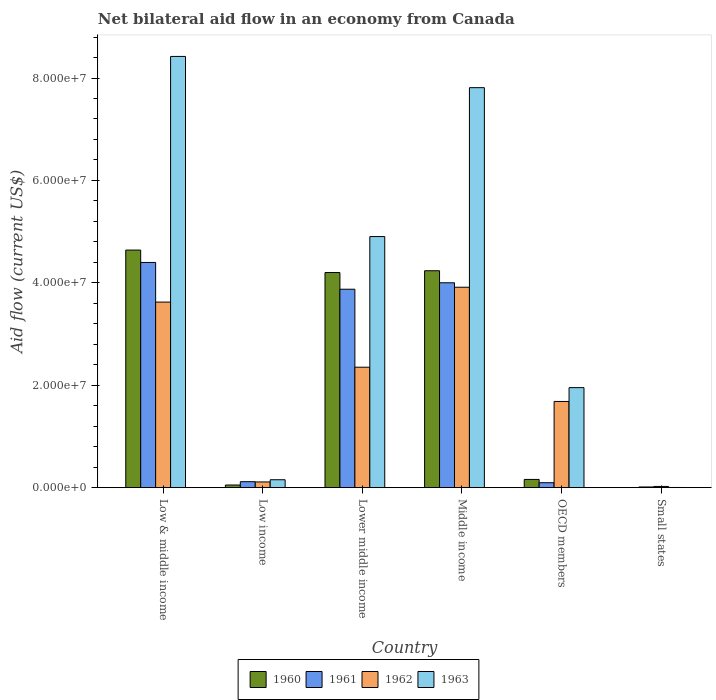How many different coloured bars are there?
Ensure brevity in your answer.  4. How many groups of bars are there?
Keep it short and to the point. 6. How many bars are there on the 1st tick from the left?
Offer a terse response. 4. What is the net bilateral aid flow in 1963 in Lower middle income?
Your response must be concise. 4.90e+07. Across all countries, what is the maximum net bilateral aid flow in 1961?
Your response must be concise. 4.40e+07. In which country was the net bilateral aid flow in 1960 maximum?
Make the answer very short. Low & middle income. In which country was the net bilateral aid flow in 1962 minimum?
Provide a short and direct response. Small states. What is the total net bilateral aid flow in 1963 in the graph?
Offer a terse response. 2.32e+08. What is the difference between the net bilateral aid flow in 1960 in Lower middle income and that in Small states?
Your answer should be compact. 4.20e+07. What is the difference between the net bilateral aid flow in 1962 in OECD members and the net bilateral aid flow in 1963 in Middle income?
Your answer should be very brief. -6.13e+07. What is the average net bilateral aid flow in 1961 per country?
Keep it short and to the point. 2.08e+07. What is the difference between the net bilateral aid flow of/in 1960 and net bilateral aid flow of/in 1961 in Low income?
Your response must be concise. -6.50e+05. What is the ratio of the net bilateral aid flow in 1960 in Low & middle income to that in Small states?
Your answer should be compact. 2320. Is the net bilateral aid flow in 1961 in Low & middle income less than that in Middle income?
Your answer should be very brief. No. Is the difference between the net bilateral aid flow in 1960 in Low & middle income and Small states greater than the difference between the net bilateral aid flow in 1961 in Low & middle income and Small states?
Your answer should be very brief. Yes. What is the difference between the highest and the second highest net bilateral aid flow in 1962?
Offer a very short reply. 1.56e+07. What is the difference between the highest and the lowest net bilateral aid flow in 1963?
Keep it short and to the point. 8.42e+07. In how many countries, is the net bilateral aid flow in 1961 greater than the average net bilateral aid flow in 1961 taken over all countries?
Provide a short and direct response. 3. Is the sum of the net bilateral aid flow in 1963 in Lower middle income and Middle income greater than the maximum net bilateral aid flow in 1961 across all countries?
Your answer should be very brief. Yes. Is it the case that in every country, the sum of the net bilateral aid flow in 1961 and net bilateral aid flow in 1960 is greater than the sum of net bilateral aid flow in 1963 and net bilateral aid flow in 1962?
Your answer should be very brief. No. What does the 2nd bar from the left in OECD members represents?
Your answer should be compact. 1961. What does the 2nd bar from the right in Small states represents?
Keep it short and to the point. 1962. Is it the case that in every country, the sum of the net bilateral aid flow in 1963 and net bilateral aid flow in 1962 is greater than the net bilateral aid flow in 1961?
Provide a short and direct response. Yes. How many bars are there?
Offer a very short reply. 24. How many countries are there in the graph?
Keep it short and to the point. 6. Does the graph contain any zero values?
Offer a very short reply. No. Does the graph contain grids?
Ensure brevity in your answer.  No. Where does the legend appear in the graph?
Offer a terse response. Bottom center. How many legend labels are there?
Your answer should be very brief. 4. What is the title of the graph?
Keep it short and to the point. Net bilateral aid flow in an economy from Canada. What is the Aid flow (current US$) in 1960 in Low & middle income?
Provide a short and direct response. 4.64e+07. What is the Aid flow (current US$) in 1961 in Low & middle income?
Ensure brevity in your answer.  4.40e+07. What is the Aid flow (current US$) of 1962 in Low & middle income?
Offer a very short reply. 3.62e+07. What is the Aid flow (current US$) in 1963 in Low & middle income?
Give a very brief answer. 8.42e+07. What is the Aid flow (current US$) of 1960 in Low income?
Ensure brevity in your answer.  5.10e+05. What is the Aid flow (current US$) in 1961 in Low income?
Your answer should be very brief. 1.16e+06. What is the Aid flow (current US$) of 1962 in Low income?
Offer a very short reply. 1.11e+06. What is the Aid flow (current US$) in 1963 in Low income?
Your answer should be compact. 1.54e+06. What is the Aid flow (current US$) in 1960 in Lower middle income?
Provide a short and direct response. 4.20e+07. What is the Aid flow (current US$) in 1961 in Lower middle income?
Your answer should be very brief. 3.88e+07. What is the Aid flow (current US$) in 1962 in Lower middle income?
Make the answer very short. 2.35e+07. What is the Aid flow (current US$) in 1963 in Lower middle income?
Ensure brevity in your answer.  4.90e+07. What is the Aid flow (current US$) in 1960 in Middle income?
Ensure brevity in your answer.  4.24e+07. What is the Aid flow (current US$) in 1961 in Middle income?
Give a very brief answer. 4.00e+07. What is the Aid flow (current US$) of 1962 in Middle income?
Make the answer very short. 3.91e+07. What is the Aid flow (current US$) in 1963 in Middle income?
Keep it short and to the point. 7.81e+07. What is the Aid flow (current US$) of 1960 in OECD members?
Your answer should be compact. 1.60e+06. What is the Aid flow (current US$) of 1961 in OECD members?
Provide a short and direct response. 9.60e+05. What is the Aid flow (current US$) in 1962 in OECD members?
Provide a succinct answer. 1.68e+07. What is the Aid flow (current US$) in 1963 in OECD members?
Your answer should be very brief. 1.95e+07. What is the Aid flow (current US$) in 1960 in Small states?
Make the answer very short. 2.00e+04. What is the Aid flow (current US$) of 1963 in Small states?
Offer a very short reply. 3.00e+04. Across all countries, what is the maximum Aid flow (current US$) of 1960?
Provide a short and direct response. 4.64e+07. Across all countries, what is the maximum Aid flow (current US$) in 1961?
Offer a terse response. 4.40e+07. Across all countries, what is the maximum Aid flow (current US$) of 1962?
Ensure brevity in your answer.  3.91e+07. Across all countries, what is the maximum Aid flow (current US$) of 1963?
Offer a very short reply. 8.42e+07. Across all countries, what is the minimum Aid flow (current US$) of 1960?
Ensure brevity in your answer.  2.00e+04. Across all countries, what is the minimum Aid flow (current US$) in 1961?
Ensure brevity in your answer.  1.30e+05. Across all countries, what is the minimum Aid flow (current US$) in 1962?
Give a very brief answer. 2.30e+05. What is the total Aid flow (current US$) in 1960 in the graph?
Keep it short and to the point. 1.33e+08. What is the total Aid flow (current US$) of 1961 in the graph?
Make the answer very short. 1.25e+08. What is the total Aid flow (current US$) in 1962 in the graph?
Your answer should be very brief. 1.17e+08. What is the total Aid flow (current US$) of 1963 in the graph?
Your response must be concise. 2.32e+08. What is the difference between the Aid flow (current US$) in 1960 in Low & middle income and that in Low income?
Your response must be concise. 4.59e+07. What is the difference between the Aid flow (current US$) of 1961 in Low & middle income and that in Low income?
Make the answer very short. 4.28e+07. What is the difference between the Aid flow (current US$) in 1962 in Low & middle income and that in Low income?
Ensure brevity in your answer.  3.51e+07. What is the difference between the Aid flow (current US$) of 1963 in Low & middle income and that in Low income?
Offer a terse response. 8.27e+07. What is the difference between the Aid flow (current US$) in 1960 in Low & middle income and that in Lower middle income?
Your answer should be very brief. 4.39e+06. What is the difference between the Aid flow (current US$) in 1961 in Low & middle income and that in Lower middle income?
Keep it short and to the point. 5.23e+06. What is the difference between the Aid flow (current US$) of 1962 in Low & middle income and that in Lower middle income?
Your response must be concise. 1.27e+07. What is the difference between the Aid flow (current US$) in 1963 in Low & middle income and that in Lower middle income?
Offer a terse response. 3.52e+07. What is the difference between the Aid flow (current US$) in 1960 in Low & middle income and that in Middle income?
Give a very brief answer. 4.04e+06. What is the difference between the Aid flow (current US$) of 1961 in Low & middle income and that in Middle income?
Your answer should be very brief. 3.97e+06. What is the difference between the Aid flow (current US$) of 1962 in Low & middle income and that in Middle income?
Provide a succinct answer. -2.90e+06. What is the difference between the Aid flow (current US$) of 1963 in Low & middle income and that in Middle income?
Offer a terse response. 6.10e+06. What is the difference between the Aid flow (current US$) in 1960 in Low & middle income and that in OECD members?
Keep it short and to the point. 4.48e+07. What is the difference between the Aid flow (current US$) in 1961 in Low & middle income and that in OECD members?
Ensure brevity in your answer.  4.30e+07. What is the difference between the Aid flow (current US$) in 1962 in Low & middle income and that in OECD members?
Your response must be concise. 1.94e+07. What is the difference between the Aid flow (current US$) of 1963 in Low & middle income and that in OECD members?
Give a very brief answer. 6.47e+07. What is the difference between the Aid flow (current US$) in 1960 in Low & middle income and that in Small states?
Your answer should be compact. 4.64e+07. What is the difference between the Aid flow (current US$) in 1961 in Low & middle income and that in Small states?
Your answer should be compact. 4.38e+07. What is the difference between the Aid flow (current US$) in 1962 in Low & middle income and that in Small states?
Make the answer very short. 3.60e+07. What is the difference between the Aid flow (current US$) in 1963 in Low & middle income and that in Small states?
Offer a terse response. 8.42e+07. What is the difference between the Aid flow (current US$) in 1960 in Low income and that in Lower middle income?
Your answer should be very brief. -4.15e+07. What is the difference between the Aid flow (current US$) of 1961 in Low income and that in Lower middle income?
Provide a succinct answer. -3.76e+07. What is the difference between the Aid flow (current US$) of 1962 in Low income and that in Lower middle income?
Keep it short and to the point. -2.24e+07. What is the difference between the Aid flow (current US$) of 1963 in Low income and that in Lower middle income?
Ensure brevity in your answer.  -4.75e+07. What is the difference between the Aid flow (current US$) of 1960 in Low income and that in Middle income?
Offer a terse response. -4.18e+07. What is the difference between the Aid flow (current US$) of 1961 in Low income and that in Middle income?
Make the answer very short. -3.88e+07. What is the difference between the Aid flow (current US$) in 1962 in Low income and that in Middle income?
Make the answer very short. -3.80e+07. What is the difference between the Aid flow (current US$) in 1963 in Low income and that in Middle income?
Your answer should be very brief. -7.66e+07. What is the difference between the Aid flow (current US$) in 1960 in Low income and that in OECD members?
Give a very brief answer. -1.09e+06. What is the difference between the Aid flow (current US$) in 1961 in Low income and that in OECD members?
Your answer should be very brief. 2.00e+05. What is the difference between the Aid flow (current US$) in 1962 in Low income and that in OECD members?
Your answer should be very brief. -1.57e+07. What is the difference between the Aid flow (current US$) of 1963 in Low income and that in OECD members?
Your answer should be very brief. -1.80e+07. What is the difference between the Aid flow (current US$) of 1960 in Low income and that in Small states?
Provide a succinct answer. 4.90e+05. What is the difference between the Aid flow (current US$) in 1961 in Low income and that in Small states?
Give a very brief answer. 1.03e+06. What is the difference between the Aid flow (current US$) in 1962 in Low income and that in Small states?
Offer a terse response. 8.80e+05. What is the difference between the Aid flow (current US$) in 1963 in Low income and that in Small states?
Your answer should be very brief. 1.51e+06. What is the difference between the Aid flow (current US$) in 1960 in Lower middle income and that in Middle income?
Offer a very short reply. -3.50e+05. What is the difference between the Aid flow (current US$) in 1961 in Lower middle income and that in Middle income?
Offer a very short reply. -1.26e+06. What is the difference between the Aid flow (current US$) in 1962 in Lower middle income and that in Middle income?
Give a very brief answer. -1.56e+07. What is the difference between the Aid flow (current US$) of 1963 in Lower middle income and that in Middle income?
Give a very brief answer. -2.91e+07. What is the difference between the Aid flow (current US$) in 1960 in Lower middle income and that in OECD members?
Give a very brief answer. 4.04e+07. What is the difference between the Aid flow (current US$) in 1961 in Lower middle income and that in OECD members?
Give a very brief answer. 3.78e+07. What is the difference between the Aid flow (current US$) in 1962 in Lower middle income and that in OECD members?
Keep it short and to the point. 6.69e+06. What is the difference between the Aid flow (current US$) of 1963 in Lower middle income and that in OECD members?
Make the answer very short. 2.95e+07. What is the difference between the Aid flow (current US$) in 1960 in Lower middle income and that in Small states?
Provide a succinct answer. 4.20e+07. What is the difference between the Aid flow (current US$) of 1961 in Lower middle income and that in Small states?
Offer a very short reply. 3.86e+07. What is the difference between the Aid flow (current US$) in 1962 in Lower middle income and that in Small states?
Offer a very short reply. 2.33e+07. What is the difference between the Aid flow (current US$) of 1963 in Lower middle income and that in Small states?
Make the answer very short. 4.90e+07. What is the difference between the Aid flow (current US$) in 1960 in Middle income and that in OECD members?
Offer a very short reply. 4.08e+07. What is the difference between the Aid flow (current US$) in 1961 in Middle income and that in OECD members?
Offer a very short reply. 3.90e+07. What is the difference between the Aid flow (current US$) of 1962 in Middle income and that in OECD members?
Ensure brevity in your answer.  2.23e+07. What is the difference between the Aid flow (current US$) in 1963 in Middle income and that in OECD members?
Offer a terse response. 5.86e+07. What is the difference between the Aid flow (current US$) in 1960 in Middle income and that in Small states?
Offer a very short reply. 4.23e+07. What is the difference between the Aid flow (current US$) in 1961 in Middle income and that in Small states?
Keep it short and to the point. 3.99e+07. What is the difference between the Aid flow (current US$) in 1962 in Middle income and that in Small states?
Your answer should be compact. 3.89e+07. What is the difference between the Aid flow (current US$) of 1963 in Middle income and that in Small states?
Your answer should be compact. 7.81e+07. What is the difference between the Aid flow (current US$) of 1960 in OECD members and that in Small states?
Your answer should be compact. 1.58e+06. What is the difference between the Aid flow (current US$) of 1961 in OECD members and that in Small states?
Your answer should be very brief. 8.30e+05. What is the difference between the Aid flow (current US$) of 1962 in OECD members and that in Small states?
Offer a terse response. 1.66e+07. What is the difference between the Aid flow (current US$) in 1963 in OECD members and that in Small states?
Your answer should be compact. 1.95e+07. What is the difference between the Aid flow (current US$) in 1960 in Low & middle income and the Aid flow (current US$) in 1961 in Low income?
Give a very brief answer. 4.52e+07. What is the difference between the Aid flow (current US$) in 1960 in Low & middle income and the Aid flow (current US$) in 1962 in Low income?
Give a very brief answer. 4.53e+07. What is the difference between the Aid flow (current US$) in 1960 in Low & middle income and the Aid flow (current US$) in 1963 in Low income?
Your response must be concise. 4.49e+07. What is the difference between the Aid flow (current US$) in 1961 in Low & middle income and the Aid flow (current US$) in 1962 in Low income?
Provide a succinct answer. 4.29e+07. What is the difference between the Aid flow (current US$) in 1961 in Low & middle income and the Aid flow (current US$) in 1963 in Low income?
Your response must be concise. 4.24e+07. What is the difference between the Aid flow (current US$) of 1962 in Low & middle income and the Aid flow (current US$) of 1963 in Low income?
Your answer should be compact. 3.47e+07. What is the difference between the Aid flow (current US$) of 1960 in Low & middle income and the Aid flow (current US$) of 1961 in Lower middle income?
Keep it short and to the point. 7.65e+06. What is the difference between the Aid flow (current US$) in 1960 in Low & middle income and the Aid flow (current US$) in 1962 in Lower middle income?
Make the answer very short. 2.29e+07. What is the difference between the Aid flow (current US$) of 1960 in Low & middle income and the Aid flow (current US$) of 1963 in Lower middle income?
Ensure brevity in your answer.  -2.64e+06. What is the difference between the Aid flow (current US$) in 1961 in Low & middle income and the Aid flow (current US$) in 1962 in Lower middle income?
Provide a short and direct response. 2.05e+07. What is the difference between the Aid flow (current US$) in 1961 in Low & middle income and the Aid flow (current US$) in 1963 in Lower middle income?
Make the answer very short. -5.06e+06. What is the difference between the Aid flow (current US$) in 1962 in Low & middle income and the Aid flow (current US$) in 1963 in Lower middle income?
Give a very brief answer. -1.28e+07. What is the difference between the Aid flow (current US$) in 1960 in Low & middle income and the Aid flow (current US$) in 1961 in Middle income?
Offer a very short reply. 6.39e+06. What is the difference between the Aid flow (current US$) of 1960 in Low & middle income and the Aid flow (current US$) of 1962 in Middle income?
Your response must be concise. 7.26e+06. What is the difference between the Aid flow (current US$) in 1960 in Low & middle income and the Aid flow (current US$) in 1963 in Middle income?
Make the answer very short. -3.17e+07. What is the difference between the Aid flow (current US$) of 1961 in Low & middle income and the Aid flow (current US$) of 1962 in Middle income?
Provide a short and direct response. 4.84e+06. What is the difference between the Aid flow (current US$) in 1961 in Low & middle income and the Aid flow (current US$) in 1963 in Middle income?
Keep it short and to the point. -3.41e+07. What is the difference between the Aid flow (current US$) in 1962 in Low & middle income and the Aid flow (current US$) in 1963 in Middle income?
Provide a short and direct response. -4.19e+07. What is the difference between the Aid flow (current US$) in 1960 in Low & middle income and the Aid flow (current US$) in 1961 in OECD members?
Your answer should be compact. 4.54e+07. What is the difference between the Aid flow (current US$) in 1960 in Low & middle income and the Aid flow (current US$) in 1962 in OECD members?
Your answer should be very brief. 2.96e+07. What is the difference between the Aid flow (current US$) in 1960 in Low & middle income and the Aid flow (current US$) in 1963 in OECD members?
Keep it short and to the point. 2.69e+07. What is the difference between the Aid flow (current US$) of 1961 in Low & middle income and the Aid flow (current US$) of 1962 in OECD members?
Your response must be concise. 2.72e+07. What is the difference between the Aid flow (current US$) in 1961 in Low & middle income and the Aid flow (current US$) in 1963 in OECD members?
Give a very brief answer. 2.44e+07. What is the difference between the Aid flow (current US$) in 1962 in Low & middle income and the Aid flow (current US$) in 1963 in OECD members?
Provide a short and direct response. 1.67e+07. What is the difference between the Aid flow (current US$) in 1960 in Low & middle income and the Aid flow (current US$) in 1961 in Small states?
Offer a terse response. 4.63e+07. What is the difference between the Aid flow (current US$) in 1960 in Low & middle income and the Aid flow (current US$) in 1962 in Small states?
Your response must be concise. 4.62e+07. What is the difference between the Aid flow (current US$) in 1960 in Low & middle income and the Aid flow (current US$) in 1963 in Small states?
Your answer should be compact. 4.64e+07. What is the difference between the Aid flow (current US$) of 1961 in Low & middle income and the Aid flow (current US$) of 1962 in Small states?
Give a very brief answer. 4.38e+07. What is the difference between the Aid flow (current US$) in 1961 in Low & middle income and the Aid flow (current US$) in 1963 in Small states?
Offer a terse response. 4.40e+07. What is the difference between the Aid flow (current US$) in 1962 in Low & middle income and the Aid flow (current US$) in 1963 in Small states?
Your response must be concise. 3.62e+07. What is the difference between the Aid flow (current US$) of 1960 in Low income and the Aid flow (current US$) of 1961 in Lower middle income?
Your response must be concise. -3.82e+07. What is the difference between the Aid flow (current US$) in 1960 in Low income and the Aid flow (current US$) in 1962 in Lower middle income?
Provide a succinct answer. -2.30e+07. What is the difference between the Aid flow (current US$) of 1960 in Low income and the Aid flow (current US$) of 1963 in Lower middle income?
Make the answer very short. -4.85e+07. What is the difference between the Aid flow (current US$) in 1961 in Low income and the Aid flow (current US$) in 1962 in Lower middle income?
Keep it short and to the point. -2.24e+07. What is the difference between the Aid flow (current US$) in 1961 in Low income and the Aid flow (current US$) in 1963 in Lower middle income?
Your answer should be very brief. -4.79e+07. What is the difference between the Aid flow (current US$) in 1962 in Low income and the Aid flow (current US$) in 1963 in Lower middle income?
Your answer should be compact. -4.79e+07. What is the difference between the Aid flow (current US$) in 1960 in Low income and the Aid flow (current US$) in 1961 in Middle income?
Offer a very short reply. -3.95e+07. What is the difference between the Aid flow (current US$) of 1960 in Low income and the Aid flow (current US$) of 1962 in Middle income?
Keep it short and to the point. -3.86e+07. What is the difference between the Aid flow (current US$) of 1960 in Low income and the Aid flow (current US$) of 1963 in Middle income?
Provide a succinct answer. -7.76e+07. What is the difference between the Aid flow (current US$) in 1961 in Low income and the Aid flow (current US$) in 1962 in Middle income?
Provide a short and direct response. -3.80e+07. What is the difference between the Aid flow (current US$) of 1961 in Low income and the Aid flow (current US$) of 1963 in Middle income?
Your answer should be compact. -7.70e+07. What is the difference between the Aid flow (current US$) of 1962 in Low income and the Aid flow (current US$) of 1963 in Middle income?
Keep it short and to the point. -7.70e+07. What is the difference between the Aid flow (current US$) of 1960 in Low income and the Aid flow (current US$) of 1961 in OECD members?
Offer a very short reply. -4.50e+05. What is the difference between the Aid flow (current US$) of 1960 in Low income and the Aid flow (current US$) of 1962 in OECD members?
Keep it short and to the point. -1.63e+07. What is the difference between the Aid flow (current US$) in 1960 in Low income and the Aid flow (current US$) in 1963 in OECD members?
Provide a succinct answer. -1.90e+07. What is the difference between the Aid flow (current US$) of 1961 in Low income and the Aid flow (current US$) of 1962 in OECD members?
Provide a short and direct response. -1.57e+07. What is the difference between the Aid flow (current US$) in 1961 in Low income and the Aid flow (current US$) in 1963 in OECD members?
Your answer should be compact. -1.84e+07. What is the difference between the Aid flow (current US$) of 1962 in Low income and the Aid flow (current US$) of 1963 in OECD members?
Offer a very short reply. -1.84e+07. What is the difference between the Aid flow (current US$) in 1960 in Low income and the Aid flow (current US$) in 1961 in Small states?
Make the answer very short. 3.80e+05. What is the difference between the Aid flow (current US$) in 1960 in Low income and the Aid flow (current US$) in 1962 in Small states?
Make the answer very short. 2.80e+05. What is the difference between the Aid flow (current US$) in 1961 in Low income and the Aid flow (current US$) in 1962 in Small states?
Give a very brief answer. 9.30e+05. What is the difference between the Aid flow (current US$) of 1961 in Low income and the Aid flow (current US$) of 1963 in Small states?
Ensure brevity in your answer.  1.13e+06. What is the difference between the Aid flow (current US$) of 1962 in Low income and the Aid flow (current US$) of 1963 in Small states?
Make the answer very short. 1.08e+06. What is the difference between the Aid flow (current US$) in 1960 in Lower middle income and the Aid flow (current US$) in 1961 in Middle income?
Make the answer very short. 2.00e+06. What is the difference between the Aid flow (current US$) in 1960 in Lower middle income and the Aid flow (current US$) in 1962 in Middle income?
Offer a terse response. 2.87e+06. What is the difference between the Aid flow (current US$) in 1960 in Lower middle income and the Aid flow (current US$) in 1963 in Middle income?
Offer a terse response. -3.61e+07. What is the difference between the Aid flow (current US$) of 1961 in Lower middle income and the Aid flow (current US$) of 1962 in Middle income?
Offer a terse response. -3.90e+05. What is the difference between the Aid flow (current US$) of 1961 in Lower middle income and the Aid flow (current US$) of 1963 in Middle income?
Offer a very short reply. -3.94e+07. What is the difference between the Aid flow (current US$) in 1962 in Lower middle income and the Aid flow (current US$) in 1963 in Middle income?
Provide a succinct answer. -5.46e+07. What is the difference between the Aid flow (current US$) of 1960 in Lower middle income and the Aid flow (current US$) of 1961 in OECD members?
Make the answer very short. 4.10e+07. What is the difference between the Aid flow (current US$) of 1960 in Lower middle income and the Aid flow (current US$) of 1962 in OECD members?
Provide a succinct answer. 2.52e+07. What is the difference between the Aid flow (current US$) in 1960 in Lower middle income and the Aid flow (current US$) in 1963 in OECD members?
Your answer should be compact. 2.25e+07. What is the difference between the Aid flow (current US$) in 1961 in Lower middle income and the Aid flow (current US$) in 1962 in OECD members?
Keep it short and to the point. 2.19e+07. What is the difference between the Aid flow (current US$) in 1961 in Lower middle income and the Aid flow (current US$) in 1963 in OECD members?
Provide a short and direct response. 1.92e+07. What is the difference between the Aid flow (current US$) of 1962 in Lower middle income and the Aid flow (current US$) of 1963 in OECD members?
Keep it short and to the point. 3.99e+06. What is the difference between the Aid flow (current US$) in 1960 in Lower middle income and the Aid flow (current US$) in 1961 in Small states?
Your answer should be compact. 4.19e+07. What is the difference between the Aid flow (current US$) of 1960 in Lower middle income and the Aid flow (current US$) of 1962 in Small states?
Your response must be concise. 4.18e+07. What is the difference between the Aid flow (current US$) in 1960 in Lower middle income and the Aid flow (current US$) in 1963 in Small states?
Give a very brief answer. 4.20e+07. What is the difference between the Aid flow (current US$) of 1961 in Lower middle income and the Aid flow (current US$) of 1962 in Small states?
Keep it short and to the point. 3.85e+07. What is the difference between the Aid flow (current US$) of 1961 in Lower middle income and the Aid flow (current US$) of 1963 in Small states?
Your answer should be very brief. 3.87e+07. What is the difference between the Aid flow (current US$) of 1962 in Lower middle income and the Aid flow (current US$) of 1963 in Small states?
Make the answer very short. 2.35e+07. What is the difference between the Aid flow (current US$) in 1960 in Middle income and the Aid flow (current US$) in 1961 in OECD members?
Your answer should be very brief. 4.14e+07. What is the difference between the Aid flow (current US$) of 1960 in Middle income and the Aid flow (current US$) of 1962 in OECD members?
Your answer should be very brief. 2.55e+07. What is the difference between the Aid flow (current US$) in 1960 in Middle income and the Aid flow (current US$) in 1963 in OECD members?
Ensure brevity in your answer.  2.28e+07. What is the difference between the Aid flow (current US$) of 1961 in Middle income and the Aid flow (current US$) of 1962 in OECD members?
Your answer should be very brief. 2.32e+07. What is the difference between the Aid flow (current US$) in 1961 in Middle income and the Aid flow (current US$) in 1963 in OECD members?
Provide a succinct answer. 2.05e+07. What is the difference between the Aid flow (current US$) of 1962 in Middle income and the Aid flow (current US$) of 1963 in OECD members?
Offer a very short reply. 1.96e+07. What is the difference between the Aid flow (current US$) of 1960 in Middle income and the Aid flow (current US$) of 1961 in Small states?
Keep it short and to the point. 4.22e+07. What is the difference between the Aid flow (current US$) in 1960 in Middle income and the Aid flow (current US$) in 1962 in Small states?
Your answer should be very brief. 4.21e+07. What is the difference between the Aid flow (current US$) of 1960 in Middle income and the Aid flow (current US$) of 1963 in Small states?
Provide a succinct answer. 4.23e+07. What is the difference between the Aid flow (current US$) in 1961 in Middle income and the Aid flow (current US$) in 1962 in Small states?
Your answer should be compact. 3.98e+07. What is the difference between the Aid flow (current US$) in 1961 in Middle income and the Aid flow (current US$) in 1963 in Small states?
Provide a short and direct response. 4.00e+07. What is the difference between the Aid flow (current US$) in 1962 in Middle income and the Aid flow (current US$) in 1963 in Small states?
Your response must be concise. 3.91e+07. What is the difference between the Aid flow (current US$) of 1960 in OECD members and the Aid flow (current US$) of 1961 in Small states?
Make the answer very short. 1.47e+06. What is the difference between the Aid flow (current US$) of 1960 in OECD members and the Aid flow (current US$) of 1962 in Small states?
Ensure brevity in your answer.  1.37e+06. What is the difference between the Aid flow (current US$) of 1960 in OECD members and the Aid flow (current US$) of 1963 in Small states?
Provide a succinct answer. 1.57e+06. What is the difference between the Aid flow (current US$) in 1961 in OECD members and the Aid flow (current US$) in 1962 in Small states?
Your answer should be compact. 7.30e+05. What is the difference between the Aid flow (current US$) in 1961 in OECD members and the Aid flow (current US$) in 1963 in Small states?
Offer a very short reply. 9.30e+05. What is the difference between the Aid flow (current US$) in 1962 in OECD members and the Aid flow (current US$) in 1963 in Small states?
Your answer should be compact. 1.68e+07. What is the average Aid flow (current US$) in 1960 per country?
Offer a terse response. 2.22e+07. What is the average Aid flow (current US$) of 1961 per country?
Your answer should be compact. 2.08e+07. What is the average Aid flow (current US$) in 1962 per country?
Provide a short and direct response. 1.95e+07. What is the average Aid flow (current US$) of 1963 per country?
Ensure brevity in your answer.  3.87e+07. What is the difference between the Aid flow (current US$) in 1960 and Aid flow (current US$) in 1961 in Low & middle income?
Your answer should be compact. 2.42e+06. What is the difference between the Aid flow (current US$) in 1960 and Aid flow (current US$) in 1962 in Low & middle income?
Make the answer very short. 1.02e+07. What is the difference between the Aid flow (current US$) in 1960 and Aid flow (current US$) in 1963 in Low & middle income?
Offer a very short reply. -3.78e+07. What is the difference between the Aid flow (current US$) in 1961 and Aid flow (current US$) in 1962 in Low & middle income?
Make the answer very short. 7.74e+06. What is the difference between the Aid flow (current US$) of 1961 and Aid flow (current US$) of 1963 in Low & middle income?
Give a very brief answer. -4.02e+07. What is the difference between the Aid flow (current US$) of 1962 and Aid flow (current US$) of 1963 in Low & middle income?
Offer a very short reply. -4.80e+07. What is the difference between the Aid flow (current US$) of 1960 and Aid flow (current US$) of 1961 in Low income?
Give a very brief answer. -6.50e+05. What is the difference between the Aid flow (current US$) of 1960 and Aid flow (current US$) of 1962 in Low income?
Keep it short and to the point. -6.00e+05. What is the difference between the Aid flow (current US$) in 1960 and Aid flow (current US$) in 1963 in Low income?
Your answer should be compact. -1.03e+06. What is the difference between the Aid flow (current US$) in 1961 and Aid flow (current US$) in 1962 in Low income?
Ensure brevity in your answer.  5.00e+04. What is the difference between the Aid flow (current US$) of 1961 and Aid flow (current US$) of 1963 in Low income?
Make the answer very short. -3.80e+05. What is the difference between the Aid flow (current US$) of 1962 and Aid flow (current US$) of 1963 in Low income?
Offer a very short reply. -4.30e+05. What is the difference between the Aid flow (current US$) of 1960 and Aid flow (current US$) of 1961 in Lower middle income?
Make the answer very short. 3.26e+06. What is the difference between the Aid flow (current US$) in 1960 and Aid flow (current US$) in 1962 in Lower middle income?
Your answer should be very brief. 1.85e+07. What is the difference between the Aid flow (current US$) of 1960 and Aid flow (current US$) of 1963 in Lower middle income?
Keep it short and to the point. -7.03e+06. What is the difference between the Aid flow (current US$) in 1961 and Aid flow (current US$) in 1962 in Lower middle income?
Give a very brief answer. 1.52e+07. What is the difference between the Aid flow (current US$) of 1961 and Aid flow (current US$) of 1963 in Lower middle income?
Ensure brevity in your answer.  -1.03e+07. What is the difference between the Aid flow (current US$) of 1962 and Aid flow (current US$) of 1963 in Lower middle income?
Your answer should be very brief. -2.55e+07. What is the difference between the Aid flow (current US$) in 1960 and Aid flow (current US$) in 1961 in Middle income?
Ensure brevity in your answer.  2.35e+06. What is the difference between the Aid flow (current US$) in 1960 and Aid flow (current US$) in 1962 in Middle income?
Provide a short and direct response. 3.22e+06. What is the difference between the Aid flow (current US$) of 1960 and Aid flow (current US$) of 1963 in Middle income?
Provide a short and direct response. -3.58e+07. What is the difference between the Aid flow (current US$) of 1961 and Aid flow (current US$) of 1962 in Middle income?
Offer a terse response. 8.70e+05. What is the difference between the Aid flow (current US$) in 1961 and Aid flow (current US$) in 1963 in Middle income?
Your answer should be very brief. -3.81e+07. What is the difference between the Aid flow (current US$) in 1962 and Aid flow (current US$) in 1963 in Middle income?
Keep it short and to the point. -3.90e+07. What is the difference between the Aid flow (current US$) of 1960 and Aid flow (current US$) of 1961 in OECD members?
Give a very brief answer. 6.40e+05. What is the difference between the Aid flow (current US$) of 1960 and Aid flow (current US$) of 1962 in OECD members?
Provide a succinct answer. -1.52e+07. What is the difference between the Aid flow (current US$) in 1960 and Aid flow (current US$) in 1963 in OECD members?
Your response must be concise. -1.79e+07. What is the difference between the Aid flow (current US$) in 1961 and Aid flow (current US$) in 1962 in OECD members?
Provide a short and direct response. -1.59e+07. What is the difference between the Aid flow (current US$) in 1961 and Aid flow (current US$) in 1963 in OECD members?
Make the answer very short. -1.86e+07. What is the difference between the Aid flow (current US$) of 1962 and Aid flow (current US$) of 1963 in OECD members?
Keep it short and to the point. -2.70e+06. What is the difference between the Aid flow (current US$) of 1960 and Aid flow (current US$) of 1962 in Small states?
Provide a succinct answer. -2.10e+05. What is the difference between the Aid flow (current US$) in 1960 and Aid flow (current US$) in 1963 in Small states?
Offer a very short reply. -10000. What is the difference between the Aid flow (current US$) of 1961 and Aid flow (current US$) of 1962 in Small states?
Give a very brief answer. -1.00e+05. What is the difference between the Aid flow (current US$) of 1962 and Aid flow (current US$) of 1963 in Small states?
Your response must be concise. 2.00e+05. What is the ratio of the Aid flow (current US$) of 1960 in Low & middle income to that in Low income?
Your answer should be very brief. 90.98. What is the ratio of the Aid flow (current US$) in 1961 in Low & middle income to that in Low income?
Make the answer very short. 37.91. What is the ratio of the Aid flow (current US$) of 1962 in Low & middle income to that in Low income?
Offer a very short reply. 32.65. What is the ratio of the Aid flow (current US$) of 1963 in Low & middle income to that in Low income?
Make the answer very short. 54.69. What is the ratio of the Aid flow (current US$) of 1960 in Low & middle income to that in Lower middle income?
Your answer should be compact. 1.1. What is the ratio of the Aid flow (current US$) of 1961 in Low & middle income to that in Lower middle income?
Your answer should be very brief. 1.14. What is the ratio of the Aid flow (current US$) in 1962 in Low & middle income to that in Lower middle income?
Offer a terse response. 1.54. What is the ratio of the Aid flow (current US$) in 1963 in Low & middle income to that in Lower middle income?
Provide a succinct answer. 1.72. What is the ratio of the Aid flow (current US$) of 1960 in Low & middle income to that in Middle income?
Make the answer very short. 1.1. What is the ratio of the Aid flow (current US$) in 1961 in Low & middle income to that in Middle income?
Your response must be concise. 1.1. What is the ratio of the Aid flow (current US$) in 1962 in Low & middle income to that in Middle income?
Give a very brief answer. 0.93. What is the ratio of the Aid flow (current US$) of 1963 in Low & middle income to that in Middle income?
Your answer should be compact. 1.08. What is the ratio of the Aid flow (current US$) in 1961 in Low & middle income to that in OECD members?
Give a very brief answer. 45.81. What is the ratio of the Aid flow (current US$) of 1962 in Low & middle income to that in OECD members?
Your response must be concise. 2.15. What is the ratio of the Aid flow (current US$) in 1963 in Low & middle income to that in OECD members?
Give a very brief answer. 4.31. What is the ratio of the Aid flow (current US$) of 1960 in Low & middle income to that in Small states?
Your answer should be very brief. 2320. What is the ratio of the Aid flow (current US$) in 1961 in Low & middle income to that in Small states?
Your response must be concise. 338.31. What is the ratio of the Aid flow (current US$) in 1962 in Low & middle income to that in Small states?
Keep it short and to the point. 157.57. What is the ratio of the Aid flow (current US$) in 1963 in Low & middle income to that in Small states?
Keep it short and to the point. 2807.33. What is the ratio of the Aid flow (current US$) in 1960 in Low income to that in Lower middle income?
Provide a succinct answer. 0.01. What is the ratio of the Aid flow (current US$) of 1961 in Low income to that in Lower middle income?
Ensure brevity in your answer.  0.03. What is the ratio of the Aid flow (current US$) in 1962 in Low income to that in Lower middle income?
Offer a terse response. 0.05. What is the ratio of the Aid flow (current US$) in 1963 in Low income to that in Lower middle income?
Provide a short and direct response. 0.03. What is the ratio of the Aid flow (current US$) in 1960 in Low income to that in Middle income?
Offer a terse response. 0.01. What is the ratio of the Aid flow (current US$) in 1961 in Low income to that in Middle income?
Offer a very short reply. 0.03. What is the ratio of the Aid flow (current US$) of 1962 in Low income to that in Middle income?
Your response must be concise. 0.03. What is the ratio of the Aid flow (current US$) of 1963 in Low income to that in Middle income?
Offer a terse response. 0.02. What is the ratio of the Aid flow (current US$) in 1960 in Low income to that in OECD members?
Provide a succinct answer. 0.32. What is the ratio of the Aid flow (current US$) of 1961 in Low income to that in OECD members?
Provide a succinct answer. 1.21. What is the ratio of the Aid flow (current US$) in 1962 in Low income to that in OECD members?
Offer a very short reply. 0.07. What is the ratio of the Aid flow (current US$) in 1963 in Low income to that in OECD members?
Give a very brief answer. 0.08. What is the ratio of the Aid flow (current US$) of 1960 in Low income to that in Small states?
Offer a very short reply. 25.5. What is the ratio of the Aid flow (current US$) in 1961 in Low income to that in Small states?
Make the answer very short. 8.92. What is the ratio of the Aid flow (current US$) of 1962 in Low income to that in Small states?
Make the answer very short. 4.83. What is the ratio of the Aid flow (current US$) of 1963 in Low income to that in Small states?
Provide a succinct answer. 51.33. What is the ratio of the Aid flow (current US$) in 1960 in Lower middle income to that in Middle income?
Your answer should be very brief. 0.99. What is the ratio of the Aid flow (current US$) in 1961 in Lower middle income to that in Middle income?
Offer a terse response. 0.97. What is the ratio of the Aid flow (current US$) in 1962 in Lower middle income to that in Middle income?
Your answer should be very brief. 0.6. What is the ratio of the Aid flow (current US$) of 1963 in Lower middle income to that in Middle income?
Offer a very short reply. 0.63. What is the ratio of the Aid flow (current US$) in 1960 in Lower middle income to that in OECD members?
Offer a very short reply. 26.26. What is the ratio of the Aid flow (current US$) of 1961 in Lower middle income to that in OECD members?
Offer a very short reply. 40.36. What is the ratio of the Aid flow (current US$) in 1962 in Lower middle income to that in OECD members?
Make the answer very short. 1.4. What is the ratio of the Aid flow (current US$) of 1963 in Lower middle income to that in OECD members?
Ensure brevity in your answer.  2.51. What is the ratio of the Aid flow (current US$) of 1960 in Lower middle income to that in Small states?
Offer a very short reply. 2100.5. What is the ratio of the Aid flow (current US$) of 1961 in Lower middle income to that in Small states?
Give a very brief answer. 298.08. What is the ratio of the Aid flow (current US$) of 1962 in Lower middle income to that in Small states?
Give a very brief answer. 102.26. What is the ratio of the Aid flow (current US$) of 1963 in Lower middle income to that in Small states?
Offer a terse response. 1634.67. What is the ratio of the Aid flow (current US$) of 1960 in Middle income to that in OECD members?
Keep it short and to the point. 26.48. What is the ratio of the Aid flow (current US$) of 1961 in Middle income to that in OECD members?
Make the answer very short. 41.68. What is the ratio of the Aid flow (current US$) in 1962 in Middle income to that in OECD members?
Keep it short and to the point. 2.33. What is the ratio of the Aid flow (current US$) in 1960 in Middle income to that in Small states?
Provide a short and direct response. 2118. What is the ratio of the Aid flow (current US$) in 1961 in Middle income to that in Small states?
Ensure brevity in your answer.  307.77. What is the ratio of the Aid flow (current US$) in 1962 in Middle income to that in Small states?
Provide a succinct answer. 170.17. What is the ratio of the Aid flow (current US$) of 1963 in Middle income to that in Small states?
Provide a short and direct response. 2604. What is the ratio of the Aid flow (current US$) in 1961 in OECD members to that in Small states?
Provide a short and direct response. 7.38. What is the ratio of the Aid flow (current US$) of 1962 in OECD members to that in Small states?
Keep it short and to the point. 73.17. What is the ratio of the Aid flow (current US$) of 1963 in OECD members to that in Small states?
Your answer should be very brief. 651. What is the difference between the highest and the second highest Aid flow (current US$) of 1960?
Your response must be concise. 4.04e+06. What is the difference between the highest and the second highest Aid flow (current US$) of 1961?
Keep it short and to the point. 3.97e+06. What is the difference between the highest and the second highest Aid flow (current US$) of 1962?
Keep it short and to the point. 2.90e+06. What is the difference between the highest and the second highest Aid flow (current US$) of 1963?
Your answer should be compact. 6.10e+06. What is the difference between the highest and the lowest Aid flow (current US$) in 1960?
Give a very brief answer. 4.64e+07. What is the difference between the highest and the lowest Aid flow (current US$) of 1961?
Provide a short and direct response. 4.38e+07. What is the difference between the highest and the lowest Aid flow (current US$) of 1962?
Your answer should be very brief. 3.89e+07. What is the difference between the highest and the lowest Aid flow (current US$) of 1963?
Your answer should be very brief. 8.42e+07. 